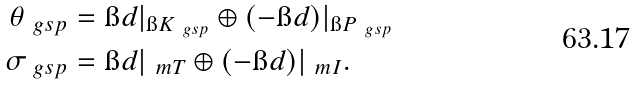Convert formula to latex. <formula><loc_0><loc_0><loc_500><loc_500>\theta _ { \ g s p } & = \i d | _ { \i K _ { \ g s p } } \oplus ( - \i d ) | _ { \i P _ { \ g s p } } \\ \sigma _ { \ g s p } & = \i d | _ { \ m T } \oplus ( - \i d ) | _ { \ m I } .</formula> 